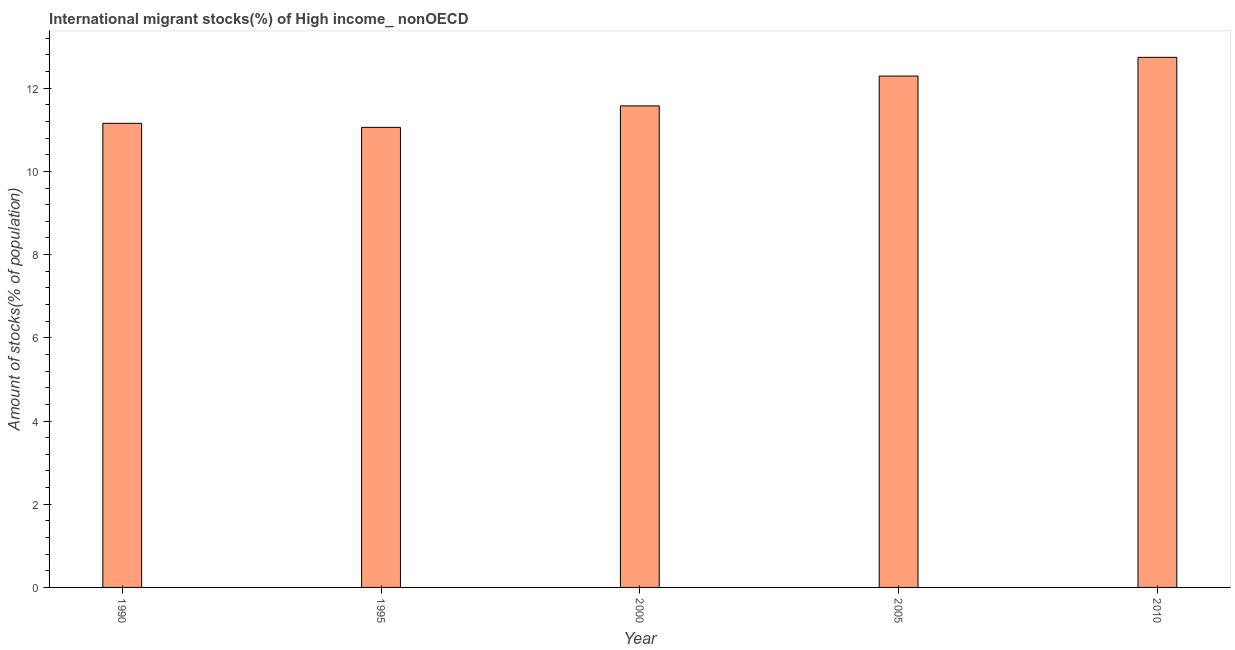Does the graph contain any zero values?
Your answer should be compact. No. Does the graph contain grids?
Ensure brevity in your answer.  No. What is the title of the graph?
Offer a terse response. International migrant stocks(%) of High income_ nonOECD. What is the label or title of the Y-axis?
Your answer should be compact. Amount of stocks(% of population). What is the number of international migrant stocks in 2000?
Offer a terse response. 11.58. Across all years, what is the maximum number of international migrant stocks?
Make the answer very short. 12.74. Across all years, what is the minimum number of international migrant stocks?
Ensure brevity in your answer.  11.06. In which year was the number of international migrant stocks minimum?
Keep it short and to the point. 1995. What is the sum of the number of international migrant stocks?
Your response must be concise. 58.83. What is the difference between the number of international migrant stocks in 1990 and 1995?
Give a very brief answer. 0.1. What is the average number of international migrant stocks per year?
Your response must be concise. 11.77. What is the median number of international migrant stocks?
Ensure brevity in your answer.  11.58. Do a majority of the years between 1990 and 2010 (inclusive) have number of international migrant stocks greater than 4 %?
Offer a terse response. Yes. What is the ratio of the number of international migrant stocks in 1990 to that in 2010?
Provide a short and direct response. 0.88. What is the difference between the highest and the second highest number of international migrant stocks?
Provide a short and direct response. 0.45. Is the sum of the number of international migrant stocks in 1995 and 2010 greater than the maximum number of international migrant stocks across all years?
Your response must be concise. Yes. What is the difference between the highest and the lowest number of international migrant stocks?
Offer a very short reply. 1.68. In how many years, is the number of international migrant stocks greater than the average number of international migrant stocks taken over all years?
Provide a succinct answer. 2. How many bars are there?
Ensure brevity in your answer.  5. How many years are there in the graph?
Give a very brief answer. 5. What is the difference between two consecutive major ticks on the Y-axis?
Provide a short and direct response. 2. What is the Amount of stocks(% of population) of 1990?
Your answer should be compact. 11.16. What is the Amount of stocks(% of population) in 1995?
Give a very brief answer. 11.06. What is the Amount of stocks(% of population) in 2000?
Give a very brief answer. 11.58. What is the Amount of stocks(% of population) in 2005?
Provide a succinct answer. 12.29. What is the Amount of stocks(% of population) in 2010?
Make the answer very short. 12.74. What is the difference between the Amount of stocks(% of population) in 1990 and 1995?
Your answer should be very brief. 0.1. What is the difference between the Amount of stocks(% of population) in 1990 and 2000?
Your answer should be very brief. -0.42. What is the difference between the Amount of stocks(% of population) in 1990 and 2005?
Your response must be concise. -1.14. What is the difference between the Amount of stocks(% of population) in 1990 and 2010?
Offer a terse response. -1.59. What is the difference between the Amount of stocks(% of population) in 1995 and 2000?
Give a very brief answer. -0.52. What is the difference between the Amount of stocks(% of population) in 1995 and 2005?
Your answer should be very brief. -1.23. What is the difference between the Amount of stocks(% of population) in 1995 and 2010?
Your response must be concise. -1.68. What is the difference between the Amount of stocks(% of population) in 2000 and 2005?
Offer a very short reply. -0.72. What is the difference between the Amount of stocks(% of population) in 2000 and 2010?
Offer a terse response. -1.17. What is the difference between the Amount of stocks(% of population) in 2005 and 2010?
Offer a terse response. -0.45. What is the ratio of the Amount of stocks(% of population) in 1990 to that in 2000?
Ensure brevity in your answer.  0.96. What is the ratio of the Amount of stocks(% of population) in 1990 to that in 2005?
Offer a terse response. 0.91. What is the ratio of the Amount of stocks(% of population) in 1990 to that in 2010?
Provide a short and direct response. 0.88. What is the ratio of the Amount of stocks(% of population) in 1995 to that in 2000?
Offer a terse response. 0.95. What is the ratio of the Amount of stocks(% of population) in 1995 to that in 2005?
Offer a terse response. 0.9. What is the ratio of the Amount of stocks(% of population) in 1995 to that in 2010?
Offer a very short reply. 0.87. What is the ratio of the Amount of stocks(% of population) in 2000 to that in 2005?
Provide a succinct answer. 0.94. What is the ratio of the Amount of stocks(% of population) in 2000 to that in 2010?
Ensure brevity in your answer.  0.91. 